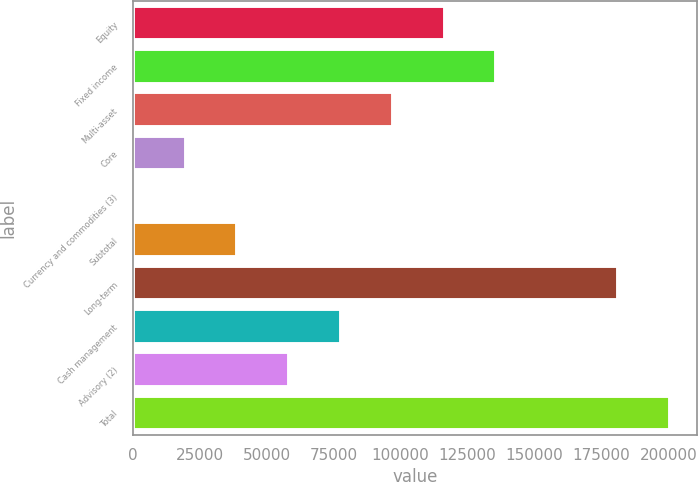Convert chart to OTSL. <chart><loc_0><loc_0><loc_500><loc_500><bar_chart><fcel>Equity<fcel>Fixed income<fcel>Multi-asset<fcel>Core<fcel>Currency and commodities (3)<fcel>Subtotal<fcel>Long-term<fcel>Cash management<fcel>Advisory (2)<fcel>Total<nl><fcel>116450<fcel>135782<fcel>97118.5<fcel>19792.5<fcel>461<fcel>39124<fcel>181253<fcel>77787<fcel>58455.5<fcel>200584<nl></chart> 